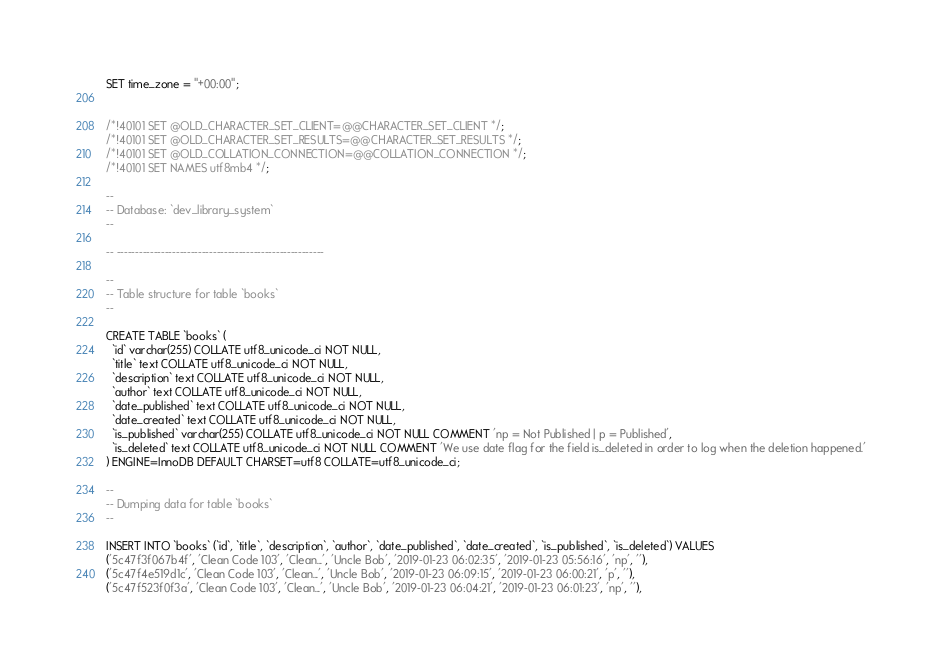Convert code to text. <code><loc_0><loc_0><loc_500><loc_500><_SQL_>SET time_zone = "+00:00";


/*!40101 SET @OLD_CHARACTER_SET_CLIENT=@@CHARACTER_SET_CLIENT */;
/*!40101 SET @OLD_CHARACTER_SET_RESULTS=@@CHARACTER_SET_RESULTS */;
/*!40101 SET @OLD_COLLATION_CONNECTION=@@COLLATION_CONNECTION */;
/*!40101 SET NAMES utf8mb4 */;

--
-- Database: `dev_library_system`
--

-- --------------------------------------------------------

--
-- Table structure for table `books`
--

CREATE TABLE `books` (
  `id` varchar(255) COLLATE utf8_unicode_ci NOT NULL,
  `title` text COLLATE utf8_unicode_ci NOT NULL,
  `description` text COLLATE utf8_unicode_ci NOT NULL,
  `author` text COLLATE utf8_unicode_ci NOT NULL,
  `date_published` text COLLATE utf8_unicode_ci NOT NULL,
  `date_created` text COLLATE utf8_unicode_ci NOT NULL,
  `is_published` varchar(255) COLLATE utf8_unicode_ci NOT NULL COMMENT 'np = Not Published | p = Published',
  `is_deleted` text COLLATE utf8_unicode_ci NOT NULL COMMENT 'We use date flag for the field is_deleted in order to log when the deletion happened.'
) ENGINE=InnoDB DEFAULT CHARSET=utf8 COLLATE=utf8_unicode_ci;

--
-- Dumping data for table `books`
--

INSERT INTO `books` (`id`, `title`, `description`, `author`, `date_published`, `date_created`, `is_published`, `is_deleted`) VALUES
('5c47f3f067b4f', 'Clean Code 103', 'Clean...', 'Uncle Bob', '2019-01-23 06:02:35', '2019-01-23 05:56:16', 'np', ''),
('5c47f4e519d1c', 'Clean Code 103', 'Clean...', 'Uncle Bob', '2019-01-23 06:09:15', '2019-01-23 06:00:21', 'p', ''),
('5c47f523f0f3a', 'Clean Code 103', 'Clean...', 'Uncle Bob', '2019-01-23 06:04:21', '2019-01-23 06:01:23', 'np', ''),</code> 